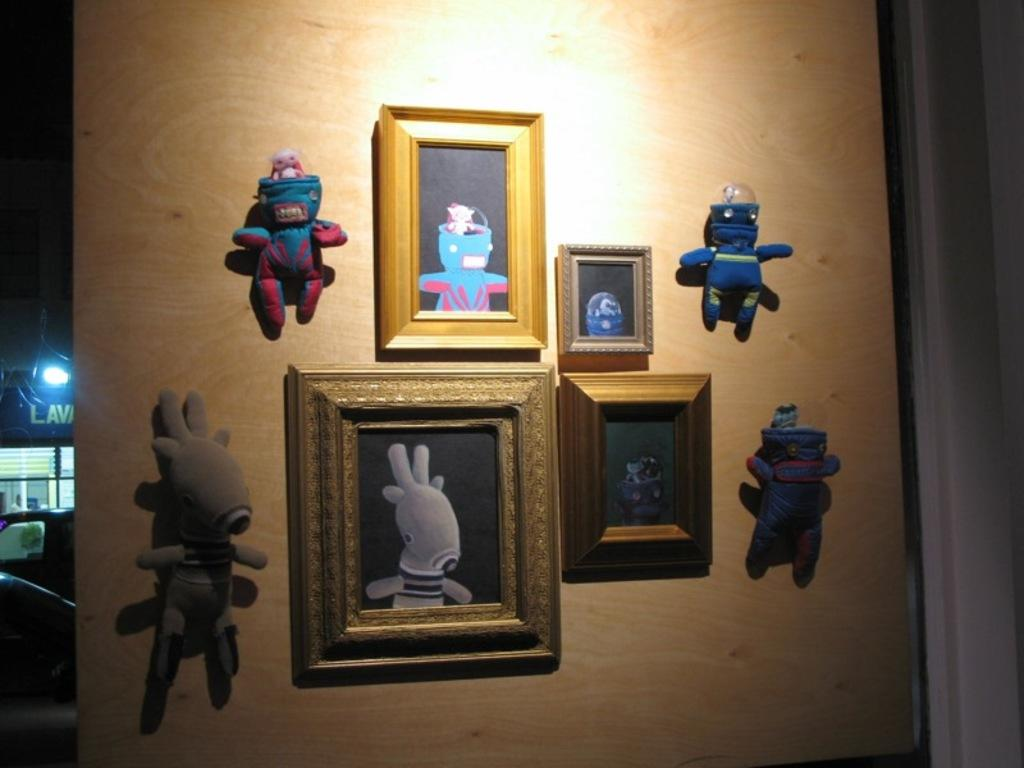What can be seen hanging on the wall in the image? Frames are visible on the wall in the image. What color is the wall that has toys attached to it? The wall is brown-colored and has toys attached to it. What can be seen providing illumination in the image? Lights are visible in the image. What is present at the back side of the image? There are objects present at the back side of the image. What type of record is being played at the meeting in the image? There is no meeting or record present in the image. Can you tell me the age of the grandfather in the image? There is no grandfather present in the image. 